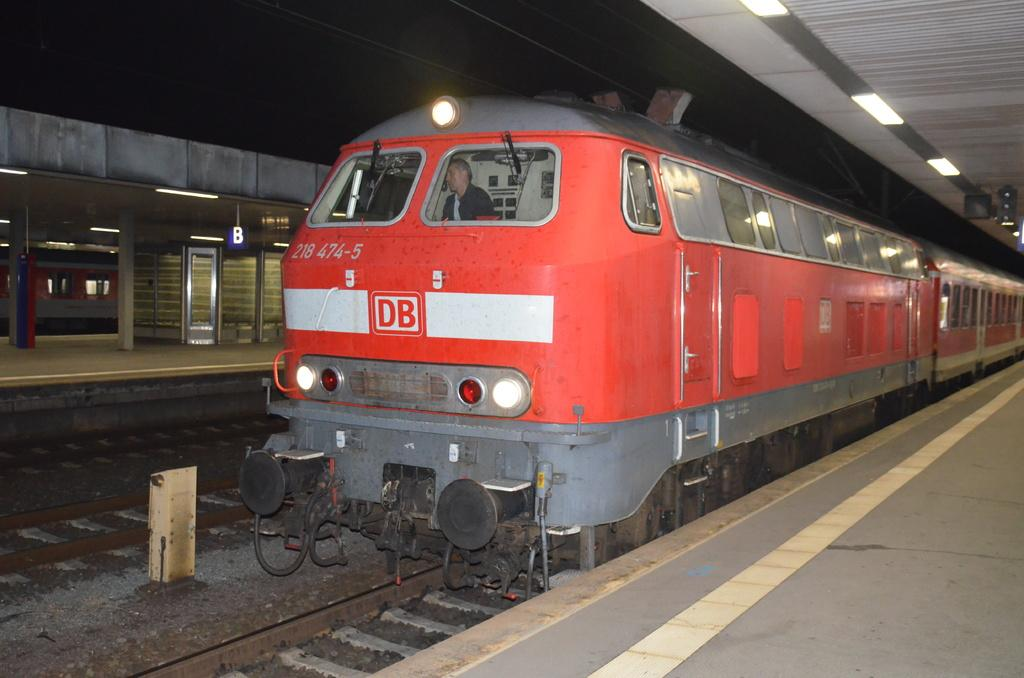What is the main subject of the image? The main subject of the image is a train. Can you describe the colors of the train? The train is red, white, and gray in color. Where is the train located in the image? The train is on a train track. Is there anyone inside the train? Yes, there is a person sitting in the train. What else can be seen in the image besides the train? The image shows a platform and a dark sky. How many snakes are slithering on the train tracks in the image? There are no snakes present in the image; it only features a train, a platform, and a dark sky. What type of drum can be heard playing in the background of the image? There is no drum or any sound present in the image; it is a still photograph. 